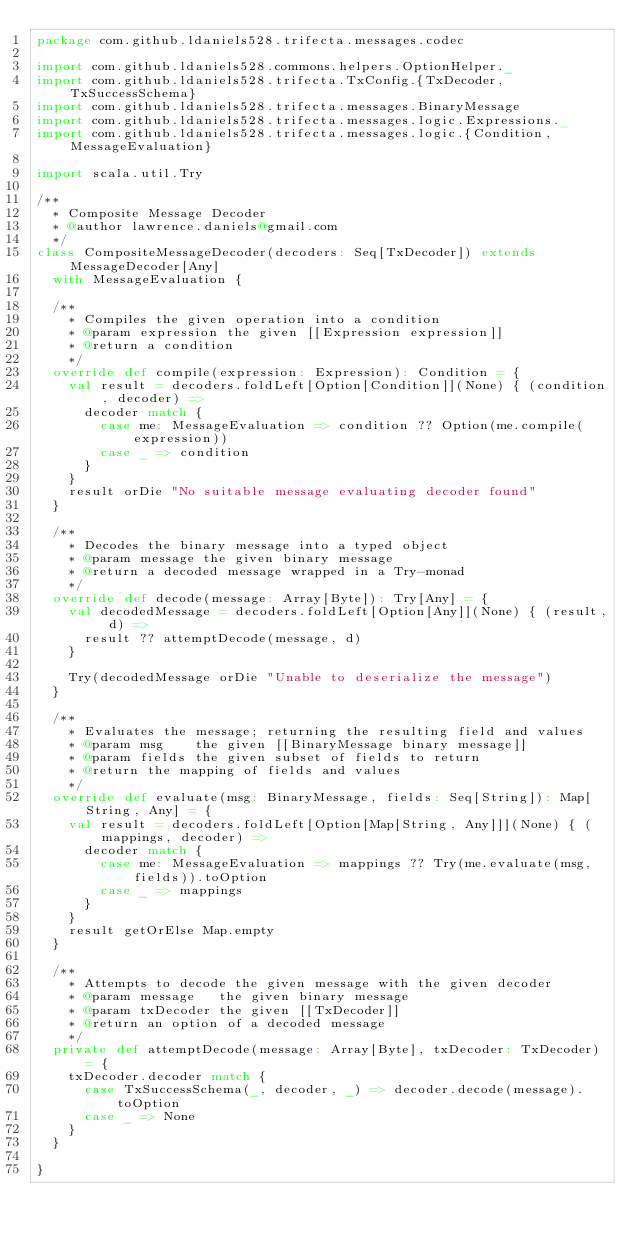Convert code to text. <code><loc_0><loc_0><loc_500><loc_500><_Scala_>package com.github.ldaniels528.trifecta.messages.codec

import com.github.ldaniels528.commons.helpers.OptionHelper._
import com.github.ldaniels528.trifecta.TxConfig.{TxDecoder, TxSuccessSchema}
import com.github.ldaniels528.trifecta.messages.BinaryMessage
import com.github.ldaniels528.trifecta.messages.logic.Expressions._
import com.github.ldaniels528.trifecta.messages.logic.{Condition, MessageEvaluation}

import scala.util.Try

/**
  * Composite Message Decoder
  * @author lawrence.daniels@gmail.com
  */
class CompositeMessageDecoder(decoders: Seq[TxDecoder]) extends MessageDecoder[Any]
  with MessageEvaluation {

  /**
    * Compiles the given operation into a condition
    * @param expression the given [[Expression expression]]
    * @return a condition
    */
  override def compile(expression: Expression): Condition = {
    val result = decoders.foldLeft[Option[Condition]](None) { (condition, decoder) =>
      decoder match {
        case me: MessageEvaluation => condition ?? Option(me.compile(expression))
        case _ => condition
      }
    }
    result orDie "No suitable message evaluating decoder found"
  }

  /**
    * Decodes the binary message into a typed object
    * @param message the given binary message
    * @return a decoded message wrapped in a Try-monad
    */
  override def decode(message: Array[Byte]): Try[Any] = {
    val decodedMessage = decoders.foldLeft[Option[Any]](None) { (result, d) =>
      result ?? attemptDecode(message, d)
    }

    Try(decodedMessage orDie "Unable to deserialize the message")
  }

  /**
    * Evaluates the message; returning the resulting field and values
    * @param msg    the given [[BinaryMessage binary message]]
    * @param fields the given subset of fields to return
    * @return the mapping of fields and values
    */
  override def evaluate(msg: BinaryMessage, fields: Seq[String]): Map[String, Any] = {
    val result = decoders.foldLeft[Option[Map[String, Any]]](None) { (mappings, decoder) =>
      decoder match {
        case me: MessageEvaluation => mappings ?? Try(me.evaluate(msg, fields)).toOption
        case _ => mappings
      }
    }
    result getOrElse Map.empty
  }

  /**
    * Attempts to decode the given message with the given decoder
    * @param message   the given binary message
    * @param txDecoder the given [[TxDecoder]]
    * @return an option of a decoded message
    */
  private def attemptDecode(message: Array[Byte], txDecoder: TxDecoder) = {
    txDecoder.decoder match {
      case TxSuccessSchema(_, decoder, _) => decoder.decode(message).toOption
      case _ => None
    }
  }

}
</code> 